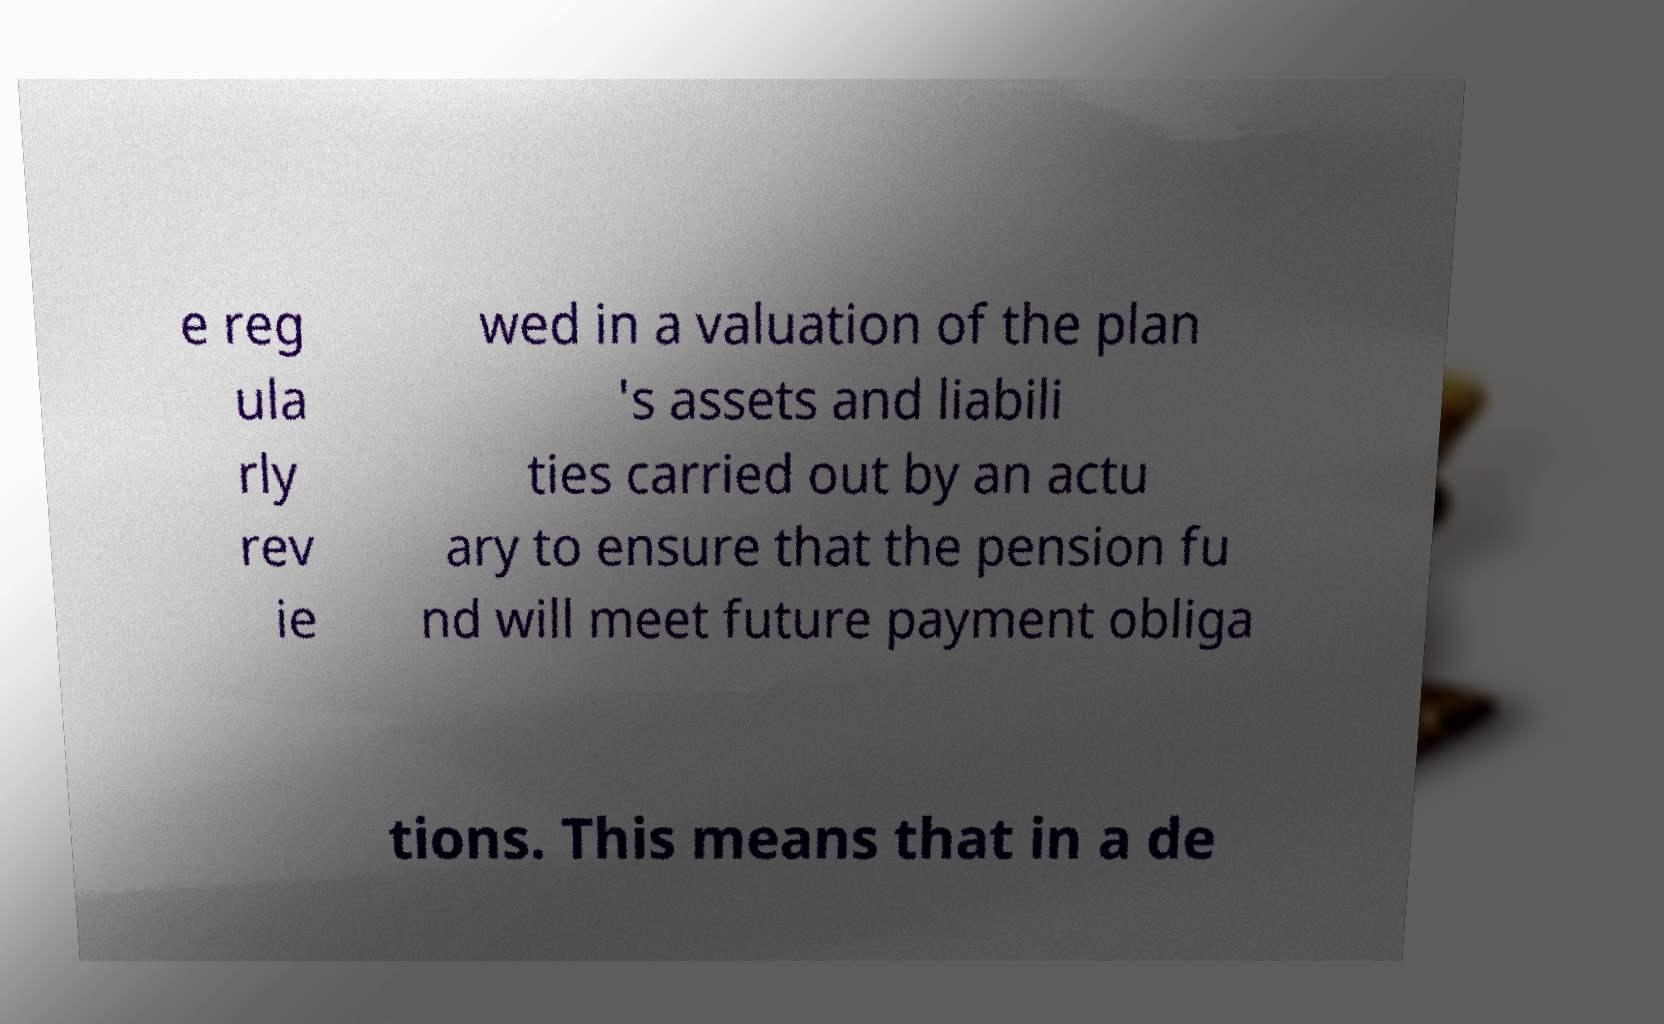I need the written content from this picture converted into text. Can you do that? e reg ula rly rev ie wed in a valuation of the plan 's assets and liabili ties carried out by an actu ary to ensure that the pension fu nd will meet future payment obliga tions. This means that in a de 